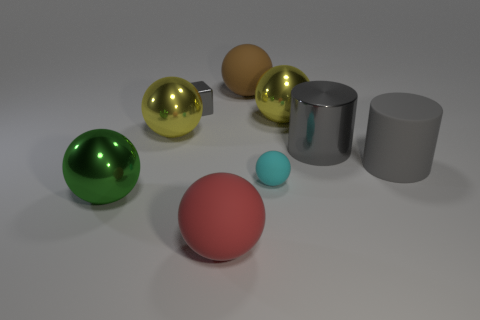What number of metal objects are right of the tiny metal block and to the left of the large gray metallic cylinder?
Offer a very short reply. 1. What material is the cube?
Your response must be concise. Metal. Are any big shiny objects visible?
Provide a succinct answer. Yes. What color is the object to the right of the big metallic cylinder?
Your response must be concise. Gray. How many big spheres are on the left side of the yellow shiny thing that is to the left of the small object on the left side of the red matte sphere?
Your answer should be very brief. 1. There is a big sphere that is on the right side of the big red ball and left of the cyan matte object; what material is it?
Make the answer very short. Rubber. Is the brown sphere made of the same material as the large yellow thing left of the small cyan ball?
Keep it short and to the point. No. Is the number of matte spheres in front of the red sphere greater than the number of big cylinders that are in front of the large brown thing?
Offer a very short reply. No. What is the shape of the big green object?
Ensure brevity in your answer.  Sphere. Do the large sphere that is behind the tiny block and the big gray thing that is to the left of the large gray rubber thing have the same material?
Provide a succinct answer. No. 